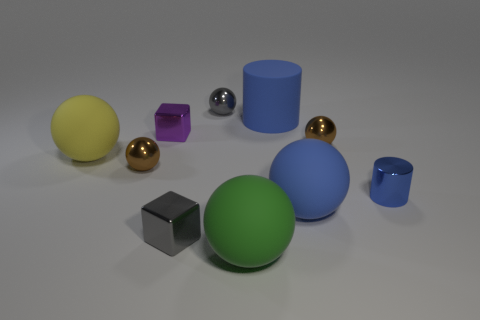Is the shape of the tiny blue thing the same as the gray metal thing behind the blue rubber ball?
Your response must be concise. No. There is a matte thing that is both behind the blue sphere and to the right of the tiny gray metal block; what size is it?
Make the answer very short. Large. What number of large metallic cubes are there?
Keep it short and to the point. 0. What material is the cylinder that is the same size as the yellow rubber ball?
Offer a very short reply. Rubber. Is there a gray cube that has the same size as the blue shiny cylinder?
Keep it short and to the point. Yes. There is a cube that is in front of the yellow rubber ball; is its color the same as the block that is behind the blue metallic cylinder?
Offer a terse response. No. How many metal things are brown spheres or big blue spheres?
Your response must be concise. 2. How many purple things are on the right side of the small purple cube in front of the blue object behind the purple metallic object?
Your answer should be compact. 0. What size is the purple thing that is made of the same material as the gray block?
Offer a very short reply. Small. How many big matte cylinders are the same color as the small metallic cylinder?
Your answer should be compact. 1. 